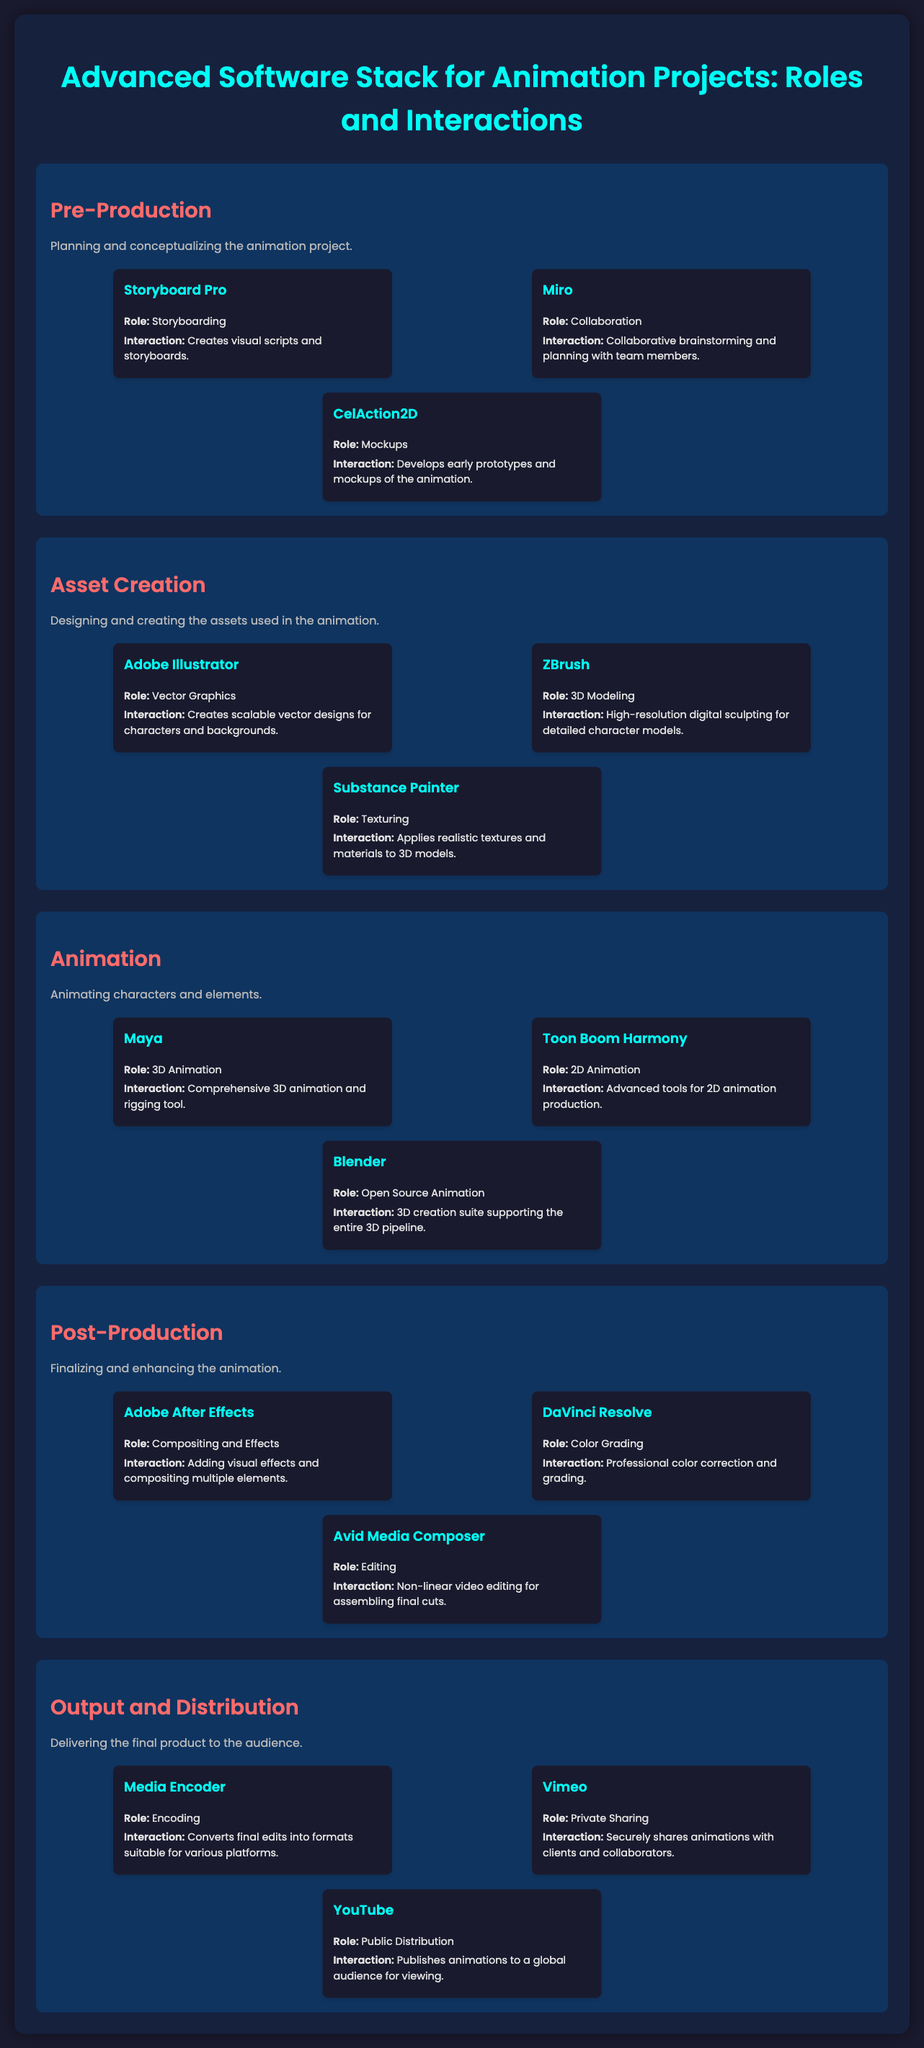What is the main focus of the "Pre-Production" layer? The main focus is on planning and conceptualizing the animation project.
Answer: Planning and conceptualizing What tool is used for storyboarding in the Pre-Production layer? The document indicates that Storyboard Pro is used for storyboarding.
Answer: Storyboard Pro Which software is responsible for 3D Animation? Maya is identified as the software responsible for 3D Animation.
Answer: Maya Name the software used for color grading in the Post-Production layer. DaVinci Resolve is the software used for color grading.
Answer: DaVinci Resolve What role does Substance Painter serve in Asset Creation? Substance Painter serves the role of texturing.
Answer: Texturing Which layer of the infographic focuses on finalizing the animation? The layer that focuses on finalizing the animation is Post-Production.
Answer: Post-Production How many components are listed under the "Output and Distribution" layer? There are three components listed under the Output and Distribution layer.
Answer: Three What interaction does the Miro software facilitate? Miro facilitates collaborative brainstorming and planning with team members.
Answer: Collaborative brainstorming and planning Which platform is used for public distribution of animations? YouTube is the platform used for public distribution.
Answer: YouTube 